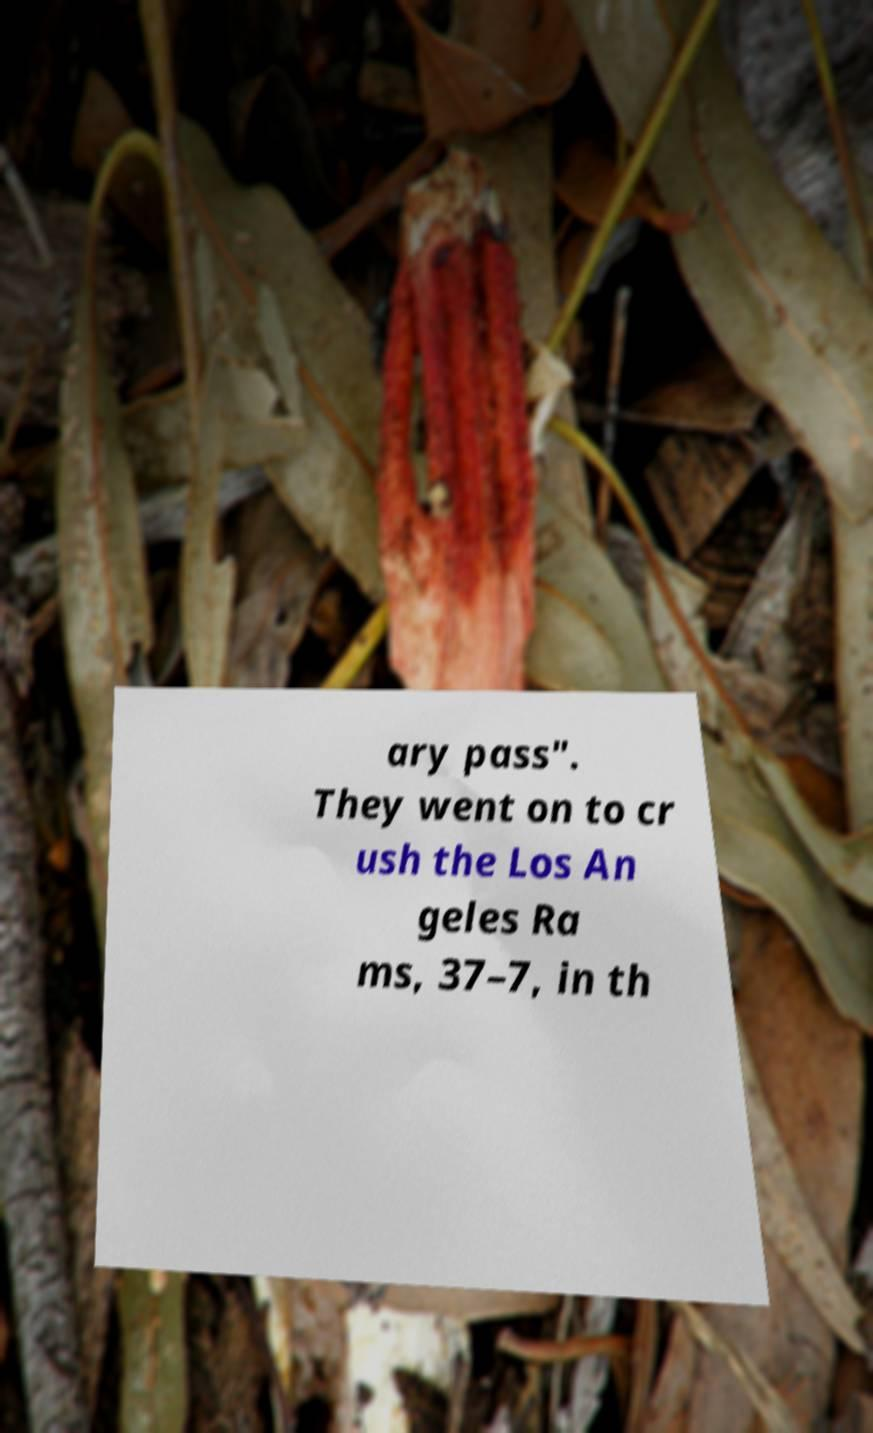Please identify and transcribe the text found in this image. ary pass". They went on to cr ush the Los An geles Ra ms, 37–7, in th 